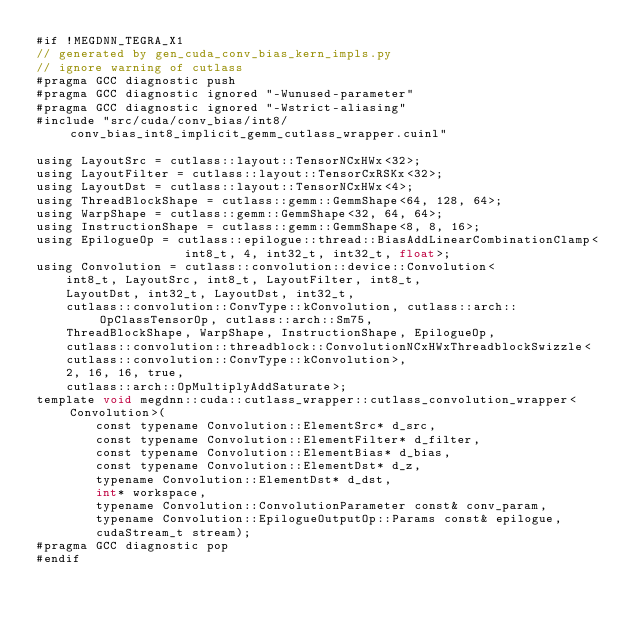Convert code to text. <code><loc_0><loc_0><loc_500><loc_500><_Cuda_>#if !MEGDNN_TEGRA_X1
// generated by gen_cuda_conv_bias_kern_impls.py
// ignore warning of cutlass
#pragma GCC diagnostic push
#pragma GCC diagnostic ignored "-Wunused-parameter"
#pragma GCC diagnostic ignored "-Wstrict-aliasing"
#include "src/cuda/conv_bias/int8/conv_bias_int8_implicit_gemm_cutlass_wrapper.cuinl"

using LayoutSrc = cutlass::layout::TensorNCxHWx<32>;
using LayoutFilter = cutlass::layout::TensorCxRSKx<32>;
using LayoutDst = cutlass::layout::TensorNCxHWx<4>;
using ThreadBlockShape = cutlass::gemm::GemmShape<64, 128, 64>;
using WarpShape = cutlass::gemm::GemmShape<32, 64, 64>;
using InstructionShape = cutlass::gemm::GemmShape<8, 8, 16>;
using EpilogueOp = cutlass::epilogue::thread::BiasAddLinearCombinationClamp<
                    int8_t, 4, int32_t, int32_t, float>;
using Convolution = cutlass::convolution::device::Convolution<
    int8_t, LayoutSrc, int8_t, LayoutFilter, int8_t, 
    LayoutDst, int32_t, LayoutDst, int32_t, 
    cutlass::convolution::ConvType::kConvolution, cutlass::arch::OpClassTensorOp, cutlass::arch::Sm75, 
    ThreadBlockShape, WarpShape, InstructionShape, EpilogueOp, 
    cutlass::convolution::threadblock::ConvolutionNCxHWxThreadblockSwizzle<
    cutlass::convolution::ConvType::kConvolution>, 
    2, 16, 16, true, 
    cutlass::arch::OpMultiplyAddSaturate>;
template void megdnn::cuda::cutlass_wrapper::cutlass_convolution_wrapper<Convolution>(
        const typename Convolution::ElementSrc* d_src, 
        const typename Convolution::ElementFilter* d_filter, 
        const typename Convolution::ElementBias* d_bias, 
        const typename Convolution::ElementDst* d_z, 
        typename Convolution::ElementDst* d_dst, 
        int* workspace, 
        typename Convolution::ConvolutionParameter const& conv_param, 
        typename Convolution::EpilogueOutputOp::Params const& epilogue, 
        cudaStream_t stream);
#pragma GCC diagnostic pop
#endif
</code> 